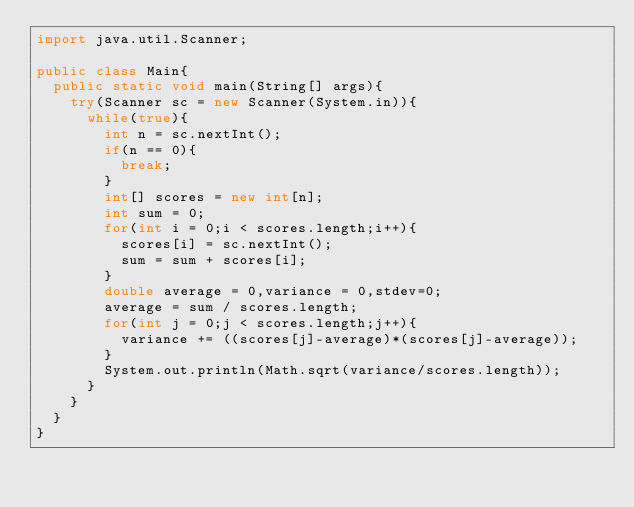<code> <loc_0><loc_0><loc_500><loc_500><_Java_>import java.util.Scanner;

public class Main{
	public static void main(String[] args){
		try(Scanner sc = new Scanner(System.in)){
			while(true){
				int n = sc.nextInt();
				if(n == 0){
					break;
				}
				int[] scores = new int[n];
				int sum = 0;
				for(int i = 0;i < scores.length;i++){
					scores[i] = sc.nextInt();
					sum = sum + scores[i];
				}
				double average = 0,variance = 0,stdev=0;
				average = sum / scores.length;
				for(int j = 0;j < scores.length;j++){
					variance += ((scores[j]-average)*(scores[j]-average));
				}
				System.out.println(Math.sqrt(variance/scores.length));
			}
		}
	}
}
</code> 